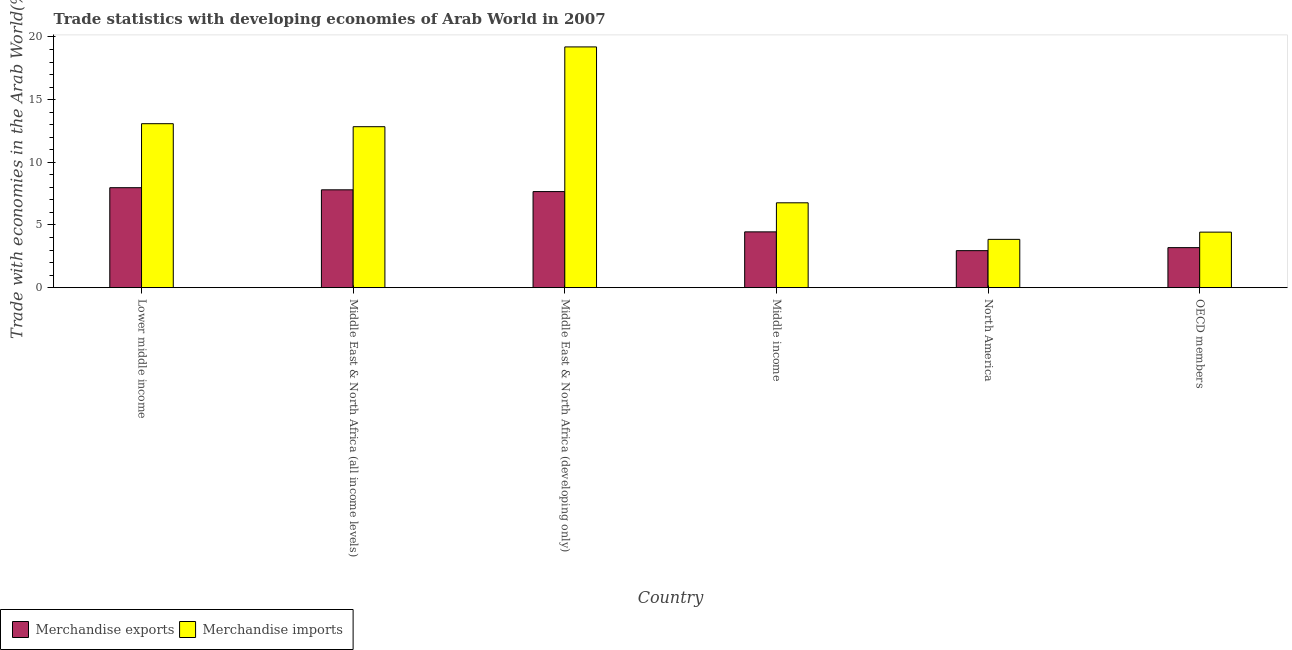How many bars are there on the 1st tick from the left?
Give a very brief answer. 2. What is the label of the 2nd group of bars from the left?
Your answer should be compact. Middle East & North Africa (all income levels). What is the merchandise imports in Lower middle income?
Your response must be concise. 13.08. Across all countries, what is the maximum merchandise imports?
Provide a short and direct response. 19.2. Across all countries, what is the minimum merchandise exports?
Make the answer very short. 2.95. In which country was the merchandise exports maximum?
Offer a terse response. Lower middle income. What is the total merchandise exports in the graph?
Offer a very short reply. 34.04. What is the difference between the merchandise imports in Lower middle income and that in Middle East & North Africa (developing only)?
Offer a terse response. -6.12. What is the difference between the merchandise imports in OECD members and the merchandise exports in Middle income?
Offer a terse response. -0.02. What is the average merchandise imports per country?
Make the answer very short. 10.03. What is the difference between the merchandise exports and merchandise imports in Middle East & North Africa (all income levels)?
Provide a succinct answer. -5.04. What is the ratio of the merchandise exports in North America to that in OECD members?
Your answer should be very brief. 0.92. Is the merchandise imports in Middle East & North Africa (all income levels) less than that in North America?
Offer a terse response. No. What is the difference between the highest and the second highest merchandise exports?
Offer a terse response. 0.17. What is the difference between the highest and the lowest merchandise imports?
Provide a succinct answer. 15.35. In how many countries, is the merchandise exports greater than the average merchandise exports taken over all countries?
Your answer should be compact. 3. Is the sum of the merchandise imports in Middle East & North Africa (all income levels) and Middle income greater than the maximum merchandise exports across all countries?
Ensure brevity in your answer.  Yes. What does the 1st bar from the left in Middle East & North Africa (all income levels) represents?
Your answer should be compact. Merchandise exports. How many bars are there?
Provide a short and direct response. 12. Are all the bars in the graph horizontal?
Offer a very short reply. No. How many countries are there in the graph?
Give a very brief answer. 6. Does the graph contain any zero values?
Offer a terse response. No. Where does the legend appear in the graph?
Offer a very short reply. Bottom left. What is the title of the graph?
Provide a short and direct response. Trade statistics with developing economies of Arab World in 2007. Does "Adolescent fertility rate" appear as one of the legend labels in the graph?
Keep it short and to the point. No. What is the label or title of the Y-axis?
Make the answer very short. Trade with economies in the Arab World(%). What is the Trade with economies in the Arab World(%) in Merchandise exports in Lower middle income?
Your answer should be very brief. 7.97. What is the Trade with economies in the Arab World(%) in Merchandise imports in Lower middle income?
Ensure brevity in your answer.  13.08. What is the Trade with economies in the Arab World(%) of Merchandise exports in Middle East & North Africa (all income levels)?
Keep it short and to the point. 7.81. What is the Trade with economies in the Arab World(%) in Merchandise imports in Middle East & North Africa (all income levels)?
Your response must be concise. 12.84. What is the Trade with economies in the Arab World(%) in Merchandise exports in Middle East & North Africa (developing only)?
Your answer should be compact. 7.66. What is the Trade with economies in the Arab World(%) in Merchandise imports in Middle East & North Africa (developing only)?
Keep it short and to the point. 19.2. What is the Trade with economies in the Arab World(%) of Merchandise exports in Middle income?
Offer a terse response. 4.45. What is the Trade with economies in the Arab World(%) of Merchandise imports in Middle income?
Your answer should be very brief. 6.77. What is the Trade with economies in the Arab World(%) in Merchandise exports in North America?
Your response must be concise. 2.95. What is the Trade with economies in the Arab World(%) of Merchandise imports in North America?
Provide a succinct answer. 3.85. What is the Trade with economies in the Arab World(%) of Merchandise exports in OECD members?
Provide a short and direct response. 3.19. What is the Trade with economies in the Arab World(%) in Merchandise imports in OECD members?
Make the answer very short. 4.43. Across all countries, what is the maximum Trade with economies in the Arab World(%) of Merchandise exports?
Offer a very short reply. 7.97. Across all countries, what is the maximum Trade with economies in the Arab World(%) of Merchandise imports?
Offer a very short reply. 19.2. Across all countries, what is the minimum Trade with economies in the Arab World(%) of Merchandise exports?
Give a very brief answer. 2.95. Across all countries, what is the minimum Trade with economies in the Arab World(%) in Merchandise imports?
Offer a terse response. 3.85. What is the total Trade with economies in the Arab World(%) in Merchandise exports in the graph?
Offer a very short reply. 34.04. What is the total Trade with economies in the Arab World(%) of Merchandise imports in the graph?
Give a very brief answer. 60.18. What is the difference between the Trade with economies in the Arab World(%) in Merchandise exports in Lower middle income and that in Middle East & North Africa (all income levels)?
Your response must be concise. 0.17. What is the difference between the Trade with economies in the Arab World(%) of Merchandise imports in Lower middle income and that in Middle East & North Africa (all income levels)?
Keep it short and to the point. 0.24. What is the difference between the Trade with economies in the Arab World(%) of Merchandise exports in Lower middle income and that in Middle East & North Africa (developing only)?
Provide a short and direct response. 0.31. What is the difference between the Trade with economies in the Arab World(%) of Merchandise imports in Lower middle income and that in Middle East & North Africa (developing only)?
Your answer should be very brief. -6.12. What is the difference between the Trade with economies in the Arab World(%) in Merchandise exports in Lower middle income and that in Middle income?
Provide a succinct answer. 3.52. What is the difference between the Trade with economies in the Arab World(%) of Merchandise imports in Lower middle income and that in Middle income?
Your answer should be very brief. 6.31. What is the difference between the Trade with economies in the Arab World(%) of Merchandise exports in Lower middle income and that in North America?
Keep it short and to the point. 5.02. What is the difference between the Trade with economies in the Arab World(%) of Merchandise imports in Lower middle income and that in North America?
Provide a short and direct response. 9.23. What is the difference between the Trade with economies in the Arab World(%) in Merchandise exports in Lower middle income and that in OECD members?
Your answer should be compact. 4.78. What is the difference between the Trade with economies in the Arab World(%) in Merchandise imports in Lower middle income and that in OECD members?
Make the answer very short. 8.65. What is the difference between the Trade with economies in the Arab World(%) of Merchandise exports in Middle East & North Africa (all income levels) and that in Middle East & North Africa (developing only)?
Make the answer very short. 0.14. What is the difference between the Trade with economies in the Arab World(%) in Merchandise imports in Middle East & North Africa (all income levels) and that in Middle East & North Africa (developing only)?
Your answer should be compact. -6.36. What is the difference between the Trade with economies in the Arab World(%) in Merchandise exports in Middle East & North Africa (all income levels) and that in Middle income?
Offer a very short reply. 3.35. What is the difference between the Trade with economies in the Arab World(%) in Merchandise imports in Middle East & North Africa (all income levels) and that in Middle income?
Keep it short and to the point. 6.07. What is the difference between the Trade with economies in the Arab World(%) of Merchandise exports in Middle East & North Africa (all income levels) and that in North America?
Provide a short and direct response. 4.85. What is the difference between the Trade with economies in the Arab World(%) in Merchandise imports in Middle East & North Africa (all income levels) and that in North America?
Offer a very short reply. 8.99. What is the difference between the Trade with economies in the Arab World(%) of Merchandise exports in Middle East & North Africa (all income levels) and that in OECD members?
Offer a terse response. 4.61. What is the difference between the Trade with economies in the Arab World(%) of Merchandise imports in Middle East & North Africa (all income levels) and that in OECD members?
Provide a succinct answer. 8.41. What is the difference between the Trade with economies in the Arab World(%) of Merchandise exports in Middle East & North Africa (developing only) and that in Middle income?
Your response must be concise. 3.21. What is the difference between the Trade with economies in the Arab World(%) of Merchandise imports in Middle East & North Africa (developing only) and that in Middle income?
Offer a very short reply. 12.44. What is the difference between the Trade with economies in the Arab World(%) in Merchandise exports in Middle East & North Africa (developing only) and that in North America?
Your answer should be compact. 4.71. What is the difference between the Trade with economies in the Arab World(%) of Merchandise imports in Middle East & North Africa (developing only) and that in North America?
Make the answer very short. 15.35. What is the difference between the Trade with economies in the Arab World(%) of Merchandise exports in Middle East & North Africa (developing only) and that in OECD members?
Make the answer very short. 4.47. What is the difference between the Trade with economies in the Arab World(%) of Merchandise imports in Middle East & North Africa (developing only) and that in OECD members?
Provide a short and direct response. 14.77. What is the difference between the Trade with economies in the Arab World(%) of Merchandise exports in Middle income and that in North America?
Give a very brief answer. 1.5. What is the difference between the Trade with economies in the Arab World(%) in Merchandise imports in Middle income and that in North America?
Offer a terse response. 2.92. What is the difference between the Trade with economies in the Arab World(%) of Merchandise exports in Middle income and that in OECD members?
Keep it short and to the point. 1.26. What is the difference between the Trade with economies in the Arab World(%) of Merchandise imports in Middle income and that in OECD members?
Keep it short and to the point. 2.34. What is the difference between the Trade with economies in the Arab World(%) of Merchandise exports in North America and that in OECD members?
Offer a terse response. -0.24. What is the difference between the Trade with economies in the Arab World(%) in Merchandise imports in North America and that in OECD members?
Offer a very short reply. -0.58. What is the difference between the Trade with economies in the Arab World(%) in Merchandise exports in Lower middle income and the Trade with economies in the Arab World(%) in Merchandise imports in Middle East & North Africa (all income levels)?
Your answer should be compact. -4.87. What is the difference between the Trade with economies in the Arab World(%) of Merchandise exports in Lower middle income and the Trade with economies in the Arab World(%) of Merchandise imports in Middle East & North Africa (developing only)?
Offer a terse response. -11.23. What is the difference between the Trade with economies in the Arab World(%) in Merchandise exports in Lower middle income and the Trade with economies in the Arab World(%) in Merchandise imports in Middle income?
Give a very brief answer. 1.21. What is the difference between the Trade with economies in the Arab World(%) of Merchandise exports in Lower middle income and the Trade with economies in the Arab World(%) of Merchandise imports in North America?
Provide a short and direct response. 4.12. What is the difference between the Trade with economies in the Arab World(%) of Merchandise exports in Lower middle income and the Trade with economies in the Arab World(%) of Merchandise imports in OECD members?
Give a very brief answer. 3.54. What is the difference between the Trade with economies in the Arab World(%) of Merchandise exports in Middle East & North Africa (all income levels) and the Trade with economies in the Arab World(%) of Merchandise imports in Middle East & North Africa (developing only)?
Ensure brevity in your answer.  -11.4. What is the difference between the Trade with economies in the Arab World(%) of Merchandise exports in Middle East & North Africa (all income levels) and the Trade with economies in the Arab World(%) of Merchandise imports in Middle income?
Keep it short and to the point. 1.04. What is the difference between the Trade with economies in the Arab World(%) in Merchandise exports in Middle East & North Africa (all income levels) and the Trade with economies in the Arab World(%) in Merchandise imports in North America?
Make the answer very short. 3.95. What is the difference between the Trade with economies in the Arab World(%) in Merchandise exports in Middle East & North Africa (all income levels) and the Trade with economies in the Arab World(%) in Merchandise imports in OECD members?
Provide a succinct answer. 3.38. What is the difference between the Trade with economies in the Arab World(%) of Merchandise exports in Middle East & North Africa (developing only) and the Trade with economies in the Arab World(%) of Merchandise imports in Middle income?
Provide a short and direct response. 0.89. What is the difference between the Trade with economies in the Arab World(%) in Merchandise exports in Middle East & North Africa (developing only) and the Trade with economies in the Arab World(%) in Merchandise imports in North America?
Your answer should be very brief. 3.81. What is the difference between the Trade with economies in the Arab World(%) of Merchandise exports in Middle East & North Africa (developing only) and the Trade with economies in the Arab World(%) of Merchandise imports in OECD members?
Offer a terse response. 3.23. What is the difference between the Trade with economies in the Arab World(%) of Merchandise exports in Middle income and the Trade with economies in the Arab World(%) of Merchandise imports in North America?
Your response must be concise. 0.6. What is the difference between the Trade with economies in the Arab World(%) of Merchandise exports in Middle income and the Trade with economies in the Arab World(%) of Merchandise imports in OECD members?
Provide a short and direct response. 0.02. What is the difference between the Trade with economies in the Arab World(%) in Merchandise exports in North America and the Trade with economies in the Arab World(%) in Merchandise imports in OECD members?
Ensure brevity in your answer.  -1.48. What is the average Trade with economies in the Arab World(%) of Merchandise exports per country?
Give a very brief answer. 5.67. What is the average Trade with economies in the Arab World(%) of Merchandise imports per country?
Ensure brevity in your answer.  10.03. What is the difference between the Trade with economies in the Arab World(%) in Merchandise exports and Trade with economies in the Arab World(%) in Merchandise imports in Lower middle income?
Ensure brevity in your answer.  -5.11. What is the difference between the Trade with economies in the Arab World(%) in Merchandise exports and Trade with economies in the Arab World(%) in Merchandise imports in Middle East & North Africa (all income levels)?
Your answer should be compact. -5.04. What is the difference between the Trade with economies in the Arab World(%) in Merchandise exports and Trade with economies in the Arab World(%) in Merchandise imports in Middle East & North Africa (developing only)?
Offer a very short reply. -11.54. What is the difference between the Trade with economies in the Arab World(%) in Merchandise exports and Trade with economies in the Arab World(%) in Merchandise imports in Middle income?
Your answer should be very brief. -2.32. What is the difference between the Trade with economies in the Arab World(%) of Merchandise exports and Trade with economies in the Arab World(%) of Merchandise imports in North America?
Offer a very short reply. -0.9. What is the difference between the Trade with economies in the Arab World(%) of Merchandise exports and Trade with economies in the Arab World(%) of Merchandise imports in OECD members?
Your answer should be compact. -1.24. What is the ratio of the Trade with economies in the Arab World(%) in Merchandise exports in Lower middle income to that in Middle East & North Africa (all income levels)?
Keep it short and to the point. 1.02. What is the ratio of the Trade with economies in the Arab World(%) of Merchandise imports in Lower middle income to that in Middle East & North Africa (all income levels)?
Keep it short and to the point. 1.02. What is the ratio of the Trade with economies in the Arab World(%) in Merchandise exports in Lower middle income to that in Middle East & North Africa (developing only)?
Ensure brevity in your answer.  1.04. What is the ratio of the Trade with economies in the Arab World(%) of Merchandise imports in Lower middle income to that in Middle East & North Africa (developing only)?
Ensure brevity in your answer.  0.68. What is the ratio of the Trade with economies in the Arab World(%) in Merchandise exports in Lower middle income to that in Middle income?
Offer a very short reply. 1.79. What is the ratio of the Trade with economies in the Arab World(%) of Merchandise imports in Lower middle income to that in Middle income?
Your answer should be very brief. 1.93. What is the ratio of the Trade with economies in the Arab World(%) of Merchandise exports in Lower middle income to that in North America?
Offer a very short reply. 2.7. What is the ratio of the Trade with economies in the Arab World(%) in Merchandise imports in Lower middle income to that in North America?
Your answer should be compact. 3.39. What is the ratio of the Trade with economies in the Arab World(%) of Merchandise exports in Lower middle income to that in OECD members?
Your answer should be compact. 2.5. What is the ratio of the Trade with economies in the Arab World(%) in Merchandise imports in Lower middle income to that in OECD members?
Ensure brevity in your answer.  2.95. What is the ratio of the Trade with economies in the Arab World(%) of Merchandise exports in Middle East & North Africa (all income levels) to that in Middle East & North Africa (developing only)?
Make the answer very short. 1.02. What is the ratio of the Trade with economies in the Arab World(%) of Merchandise imports in Middle East & North Africa (all income levels) to that in Middle East & North Africa (developing only)?
Provide a short and direct response. 0.67. What is the ratio of the Trade with economies in the Arab World(%) of Merchandise exports in Middle East & North Africa (all income levels) to that in Middle income?
Offer a terse response. 1.75. What is the ratio of the Trade with economies in the Arab World(%) in Merchandise imports in Middle East & North Africa (all income levels) to that in Middle income?
Keep it short and to the point. 1.9. What is the ratio of the Trade with economies in the Arab World(%) of Merchandise exports in Middle East & North Africa (all income levels) to that in North America?
Your response must be concise. 2.64. What is the ratio of the Trade with economies in the Arab World(%) of Merchandise imports in Middle East & North Africa (all income levels) to that in North America?
Offer a terse response. 3.33. What is the ratio of the Trade with economies in the Arab World(%) in Merchandise exports in Middle East & North Africa (all income levels) to that in OECD members?
Your answer should be compact. 2.44. What is the ratio of the Trade with economies in the Arab World(%) in Merchandise imports in Middle East & North Africa (all income levels) to that in OECD members?
Your response must be concise. 2.9. What is the ratio of the Trade with economies in the Arab World(%) of Merchandise exports in Middle East & North Africa (developing only) to that in Middle income?
Provide a succinct answer. 1.72. What is the ratio of the Trade with economies in the Arab World(%) in Merchandise imports in Middle East & North Africa (developing only) to that in Middle income?
Ensure brevity in your answer.  2.84. What is the ratio of the Trade with economies in the Arab World(%) of Merchandise exports in Middle East & North Africa (developing only) to that in North America?
Your response must be concise. 2.6. What is the ratio of the Trade with economies in the Arab World(%) of Merchandise imports in Middle East & North Africa (developing only) to that in North America?
Offer a very short reply. 4.98. What is the ratio of the Trade with economies in the Arab World(%) in Merchandise imports in Middle East & North Africa (developing only) to that in OECD members?
Provide a succinct answer. 4.33. What is the ratio of the Trade with economies in the Arab World(%) in Merchandise exports in Middle income to that in North America?
Your response must be concise. 1.51. What is the ratio of the Trade with economies in the Arab World(%) of Merchandise imports in Middle income to that in North America?
Make the answer very short. 1.76. What is the ratio of the Trade with economies in the Arab World(%) of Merchandise exports in Middle income to that in OECD members?
Your response must be concise. 1.39. What is the ratio of the Trade with economies in the Arab World(%) in Merchandise imports in Middle income to that in OECD members?
Make the answer very short. 1.53. What is the ratio of the Trade with economies in the Arab World(%) in Merchandise exports in North America to that in OECD members?
Ensure brevity in your answer.  0.92. What is the ratio of the Trade with economies in the Arab World(%) of Merchandise imports in North America to that in OECD members?
Ensure brevity in your answer.  0.87. What is the difference between the highest and the second highest Trade with economies in the Arab World(%) of Merchandise exports?
Your answer should be compact. 0.17. What is the difference between the highest and the second highest Trade with economies in the Arab World(%) of Merchandise imports?
Ensure brevity in your answer.  6.12. What is the difference between the highest and the lowest Trade with economies in the Arab World(%) of Merchandise exports?
Offer a very short reply. 5.02. What is the difference between the highest and the lowest Trade with economies in the Arab World(%) in Merchandise imports?
Offer a very short reply. 15.35. 